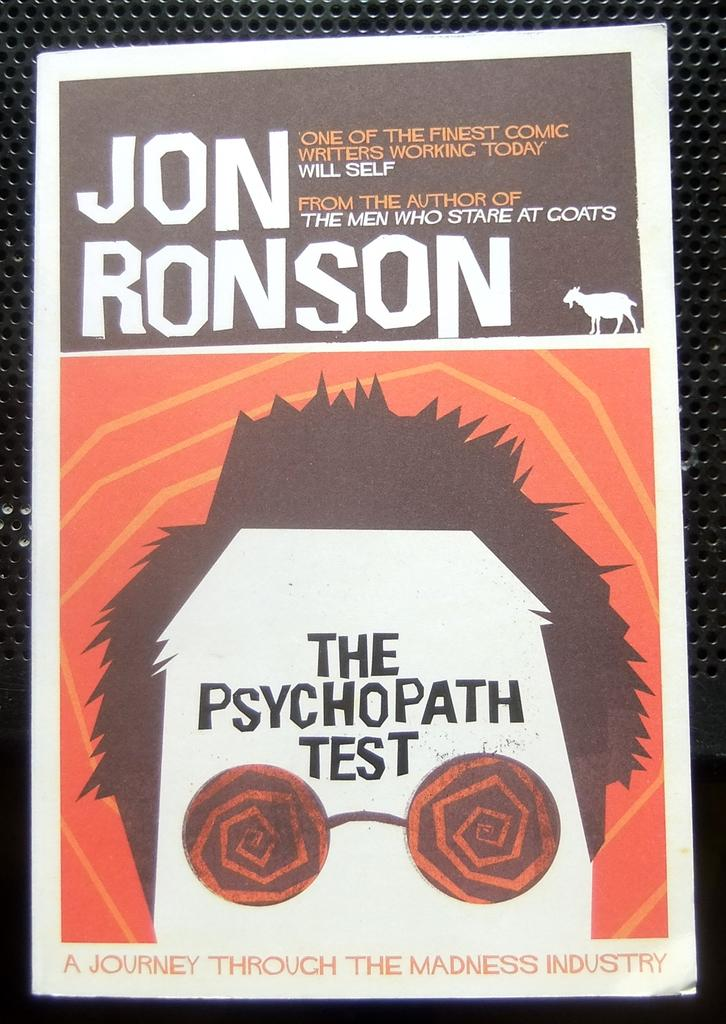<image>
Describe the image concisely. A book that says The Psychopathic Test on the cover 